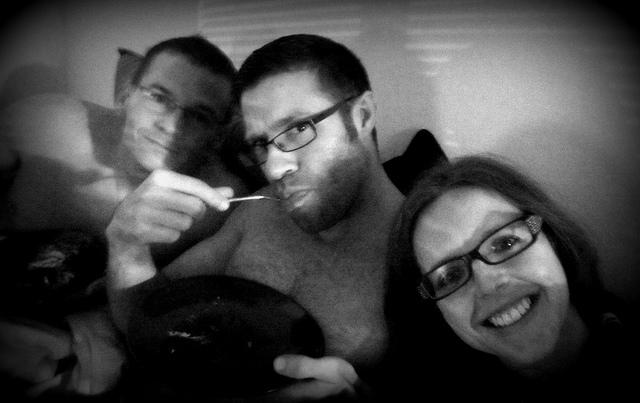What is on the women's head?
Give a very brief answer. Hair. Does the girl have a shirt on?
Write a very short answer. Yes. Is somebody using a calculator?
Be succinct. No. Are there more women than men here?
Write a very short answer. No. How many people are wearing glasses?
Write a very short answer. 3. Are there more guys than girls in this photo?
Quick response, please. Yes. Are both men wearing glasses?
Answer briefly. Yes. 